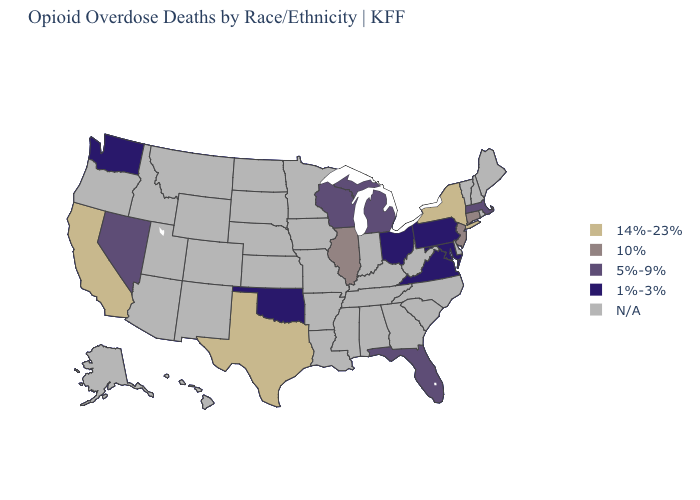What is the value of Wisconsin?
Short answer required. 5%-9%. Name the states that have a value in the range 5%-9%?
Short answer required. Florida, Massachusetts, Michigan, Nevada, Wisconsin. Name the states that have a value in the range 14%-23%?
Short answer required. California, New York, Texas. What is the highest value in the MidWest ?
Give a very brief answer. 10%. Among the states that border Connecticut , which have the highest value?
Answer briefly. New York. Name the states that have a value in the range 10%?
Be succinct. Connecticut, Illinois, New Jersey. What is the value of Missouri?
Keep it brief. N/A. Is the legend a continuous bar?
Concise answer only. No. Name the states that have a value in the range 14%-23%?
Concise answer only. California, New York, Texas. What is the value of Maine?
Concise answer only. N/A. Which states have the lowest value in the West?
Quick response, please. Washington. Name the states that have a value in the range 1%-3%?
Give a very brief answer. Maryland, Ohio, Oklahoma, Pennsylvania, Virginia, Washington. What is the highest value in the Northeast ?
Short answer required. 14%-23%. What is the highest value in the MidWest ?
Keep it brief. 10%. 